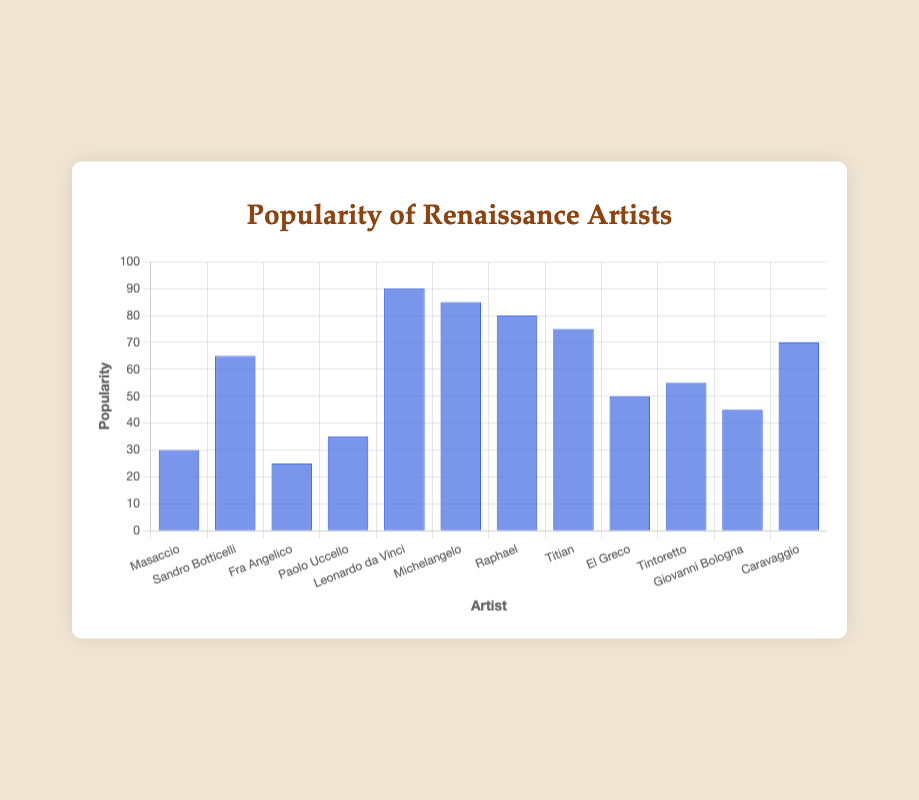Which period has the most popular artist overall? To answer this, we examine the popularity of the top artist in each period. The "High Renaissance" has Leonardo da Vinci with a popularity of 90, which is higher than any artist from the "Early Renaissance" or "Late Renaissance".
Answer: High Renaissance Who is the most popular artist in the Late Renaissance period? We look only at the data points corresponding to the "Late Renaissance" artists. Among El Greco (50), Tintoretto (55), Giovanni Bologna (45), and Caravaggio (70), Caravaggio has the highest popularity.
Answer: Caravaggio Is Michelangelo more popular than Sandro Botticelli? We compare the popularity values of Michelangelo (85) and Sandro Botticelli (65). Since 85 is greater than 65, Michelangelo is more popular.
Answer: Yes What is the total popularity of all High Renaissance artists? Adding the popularity of Leonardo da Vinci (90), Michelangelo (85), Raphael (80), and Titian (75): 90 + 85 + 80 + 75 = 330
Answer: 330 Which period has the least popular artist, and who is that artist? We identify the least popular artist in each period. Early: Fra Angelico (25); High: Titian (75); Late: Giovanni Bologna (45). Fra Angelico has the lowest popularity (25).
Answer: Early Renaissance, Fra Angelico What is the difference in popularity between Leonardo da Vinci and Caravaggio? Subtract Caravaggio's popularity (70) from Leonardo da Vinci's popularity (90): 90 - 70 = 20
Answer: 20 On average, which period has more popular artists: Early Renaissance or Late Renaissance? Calculate the mean popularity for both periods. Early: (30 + 65 + 25 + 35)/4 = 38.75; Late: (50 + 55 + 45 + 70)/4 = 55. Late Renaissance has a higher average popularity.
Answer: Late Renaissance Who is the third most popular artist overall? List the artists by popularity in descending order. The third most popular artist overall is Raphael with a popularity of 80.
Answer: Raphael How much more popular is Titian compared to Paolo Uccello? Subtract Paolo Uccello's popularity (35) from Titian's popularity (75): 75 - 35 = 40
Answer: 40 